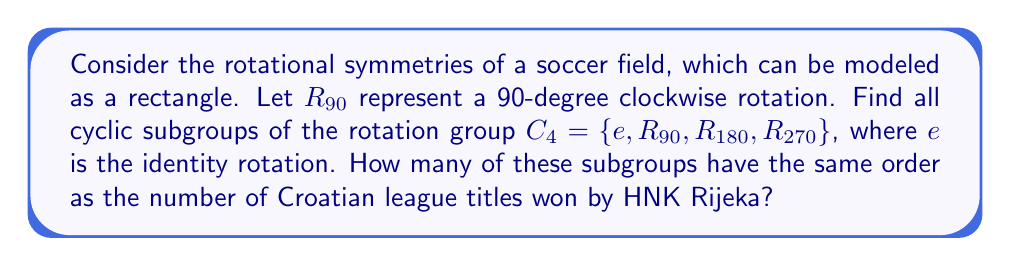Could you help me with this problem? To solve this problem, we need to follow these steps:

1) First, let's identify all the elements of the rotation group $C_4$:
   $e$ (identity), $R_{90}$, $R_{180}$, $R_{270}$

2) Now, let's find all cyclic subgroups by considering each element:

   a) $\langle e \rangle = \{e\}$
      Order: 1

   b) $\langle R_{90} \rangle = \{e, R_{90}, R_{180}, R_{270}\}$
      Order: 4

   c) $\langle R_{180} \rangle = \{e, R_{180}\}$
      Order: 2

   d) $\langle R_{270} \rangle = \{e, R_{90}, R_{180}, R_{270}\}$
      Order: 4

3) We can see that there are 4 cyclic subgroups in total:
   $\{e\}$, $\{e, R_{90}, R_{180}, R_{270}\}$, $\{e, R_{180}\}$, and $\{e, R_{90}, R_{180}, R_{270}\}$

4) The orders of these subgroups are 1, 4, 2, and 4 respectively.

5) HNK Rijeka has won 1 Croatian league title (in the 2016-17 season).

6) Therefore, we need to count how many subgroups have order 1.

There is only one subgroup with order 1, which is $\{e\}$.
Answer: The rotation group $C_4$ has 4 cyclic subgroups in total, and 1 of these subgroups has the same order as the number of Croatian league titles won by HNK Rijeka. 